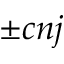<formula> <loc_0><loc_0><loc_500><loc_500>\pm c n j</formula> 